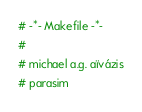Convert code to text. <code><loc_0><loc_0><loc_500><loc_500><_ObjectiveC_># -*- Makefile -*-
#
# michael a.g. aïvázis
# parasim</code> 